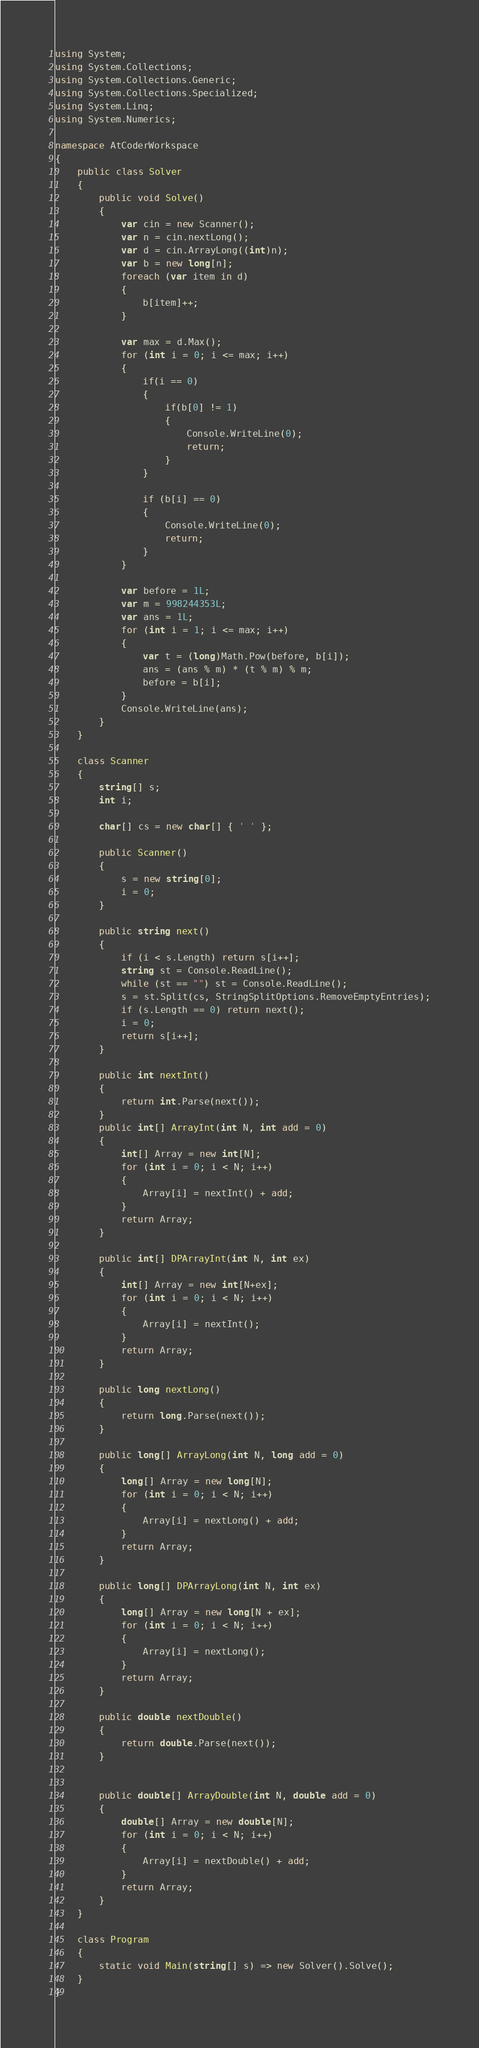Convert code to text. <code><loc_0><loc_0><loc_500><loc_500><_C#_>using System;
using System.Collections;
using System.Collections.Generic;
using System.Collections.Specialized;
using System.Linq;
using System.Numerics;

namespace AtCoderWorkspace
{
    public class Solver
    {
        public void Solve()
        {
            var cin = new Scanner();
            var n = cin.nextLong();
            var d = cin.ArrayLong((int)n);
            var b = new long[n];
            foreach (var item in d)
            {
                b[item]++;
            }

            var max = d.Max();
            for (int i = 0; i <= max; i++)
            {
                if(i == 0)
                {
                    if(b[0] != 1)
                    {
                        Console.WriteLine(0);
                        return;
                    }
                }

                if (b[i] == 0)
                {
                    Console.WriteLine(0);
                    return;
                }
            }            

            var before = 1L;
            var m = 998244353L; 
            var ans = 1L;            
            for (int i = 1; i <= max; i++)
            {
                var t = (long)Math.Pow(before, b[i]);
                ans = (ans % m) * (t % m) % m;
                before = b[i];
            }
            Console.WriteLine(ans);
        }
    }

    class Scanner
    {
        string[] s;
        int i;

        char[] cs = new char[] { ' ' };

        public Scanner()
        {
            s = new string[0];
            i = 0;
        }

        public string next()
        {
            if (i < s.Length) return s[i++];
            string st = Console.ReadLine();
            while (st == "") st = Console.ReadLine();
            s = st.Split(cs, StringSplitOptions.RemoveEmptyEntries);
            if (s.Length == 0) return next();
            i = 0;
            return s[i++];
        }

        public int nextInt()
        {
            return int.Parse(next());
        }
        public int[] ArrayInt(int N, int add = 0)
        {
            int[] Array = new int[N];
            for (int i = 0; i < N; i++)
            {
                Array[i] = nextInt() + add;
            }
            return Array;
        }

        public int[] DPArrayInt(int N, int ex)
        {
            int[] Array = new int[N+ex];
            for (int i = 0; i < N; i++)
            {
                Array[i] = nextInt();
            }
            return Array;
        }

        public long nextLong()
        {
            return long.Parse(next());
        }

        public long[] ArrayLong(int N, long add = 0)
        {
            long[] Array = new long[N];
            for (int i = 0; i < N; i++)
            {
                Array[i] = nextLong() + add;
            }
            return Array;
        }

        public long[] DPArrayLong(int N, int ex)
        {
            long[] Array = new long[N + ex];
            for (int i = 0; i < N; i++)
            {
                Array[i] = nextLong();
            }
            return Array;
        }

        public double nextDouble()
        {
            return double.Parse(next());
        }


        public double[] ArrayDouble(int N, double add = 0)
        {
            double[] Array = new double[N];
            for (int i = 0; i < N; i++)
            {
                Array[i] = nextDouble() + add;
            }
            return Array;
        }
    }   

    class Program
    {
        static void Main(string[] s) => new Solver().Solve();
    }
}
</code> 